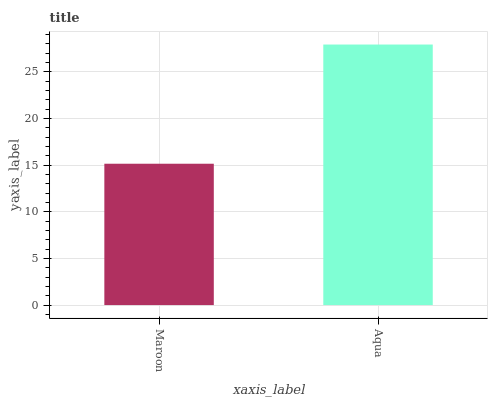Is Maroon the minimum?
Answer yes or no. Yes. Is Aqua the maximum?
Answer yes or no. Yes. Is Aqua the minimum?
Answer yes or no. No. Is Aqua greater than Maroon?
Answer yes or no. Yes. Is Maroon less than Aqua?
Answer yes or no. Yes. Is Maroon greater than Aqua?
Answer yes or no. No. Is Aqua less than Maroon?
Answer yes or no. No. Is Aqua the high median?
Answer yes or no. Yes. Is Maroon the low median?
Answer yes or no. Yes. Is Maroon the high median?
Answer yes or no. No. Is Aqua the low median?
Answer yes or no. No. 